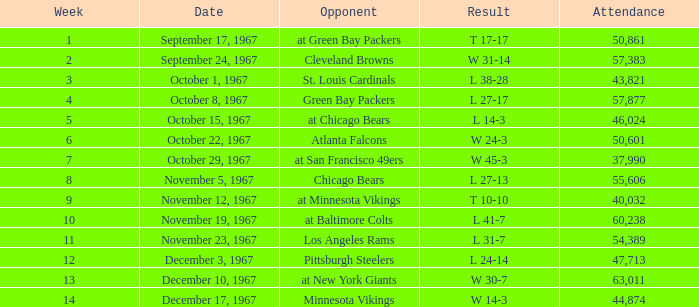How many weeks yield a result of t 10-10? 1.0. 